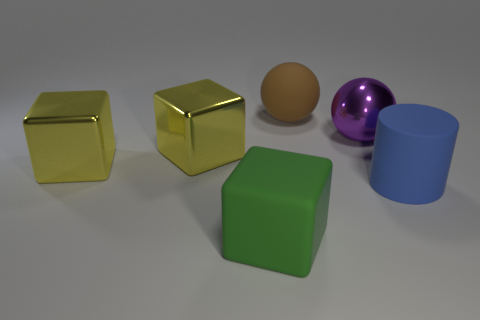What number of objects are purple shiny spheres left of the blue thing or large things that are behind the large blue rubber cylinder?
Make the answer very short. 4. Are there the same number of large green things right of the large blue rubber object and purple spheres that are in front of the brown ball?
Provide a succinct answer. No. There is a shiny object that is right of the large green object; what color is it?
Your response must be concise. Purple. There is a large metallic ball; is its color the same as the matte thing that is behind the big matte cylinder?
Your answer should be very brief. No. Are there fewer cylinders than large yellow things?
Offer a very short reply. Yes. Do the big metal thing on the right side of the matte cube and the matte ball have the same color?
Provide a succinct answer. No. What number of other red blocks have the same size as the matte block?
Ensure brevity in your answer.  0. Is there a cylinder of the same color as the rubber sphere?
Offer a terse response. No. Does the brown sphere have the same material as the big green block?
Make the answer very short. Yes. How many big yellow things are the same shape as the big purple object?
Make the answer very short. 0. 